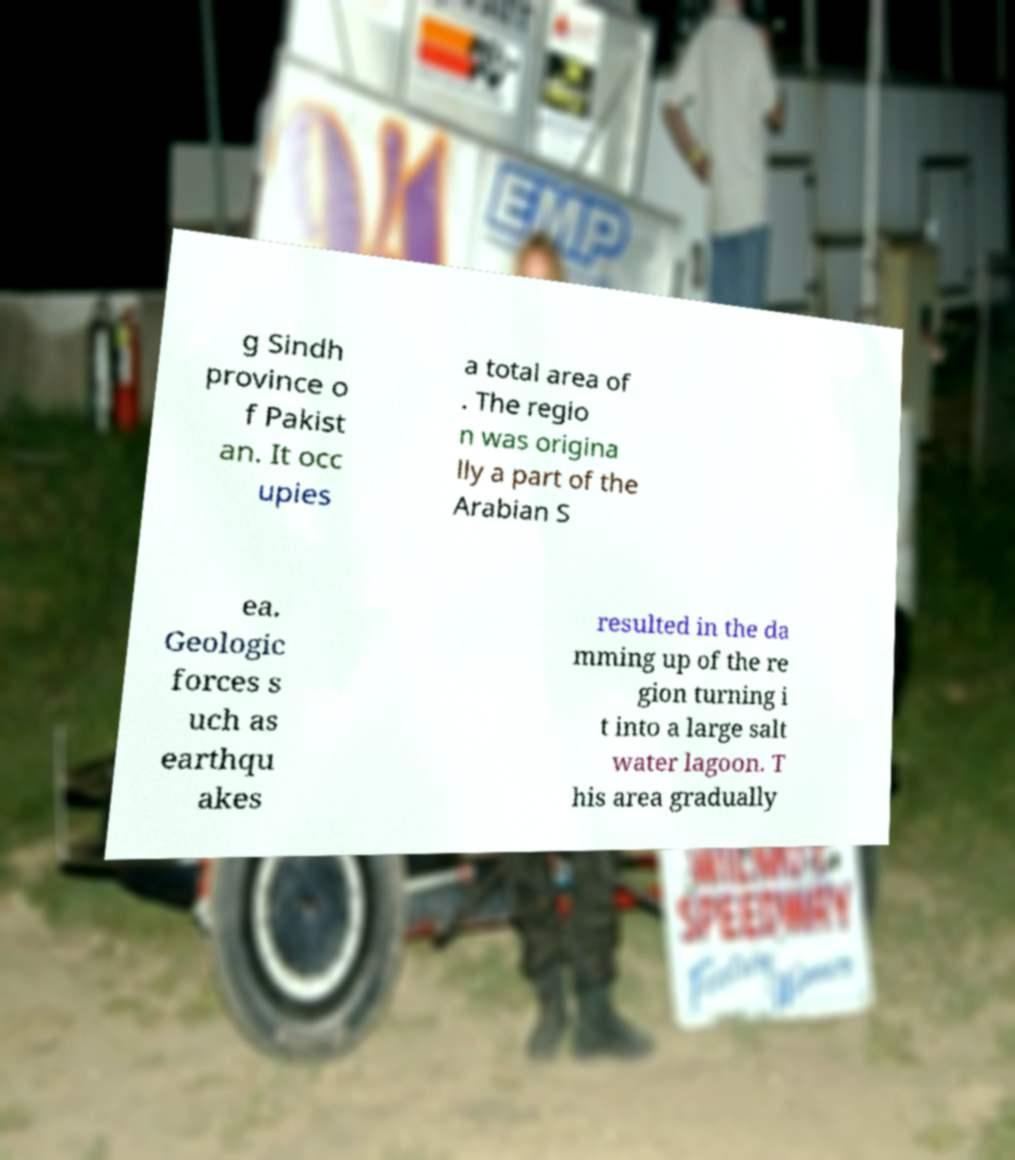Could you assist in decoding the text presented in this image and type it out clearly? g Sindh province o f Pakist an. It occ upies a total area of . The regio n was origina lly a part of the Arabian S ea. Geologic forces s uch as earthqu akes resulted in the da mming up of the re gion turning i t into a large salt water lagoon. T his area gradually 